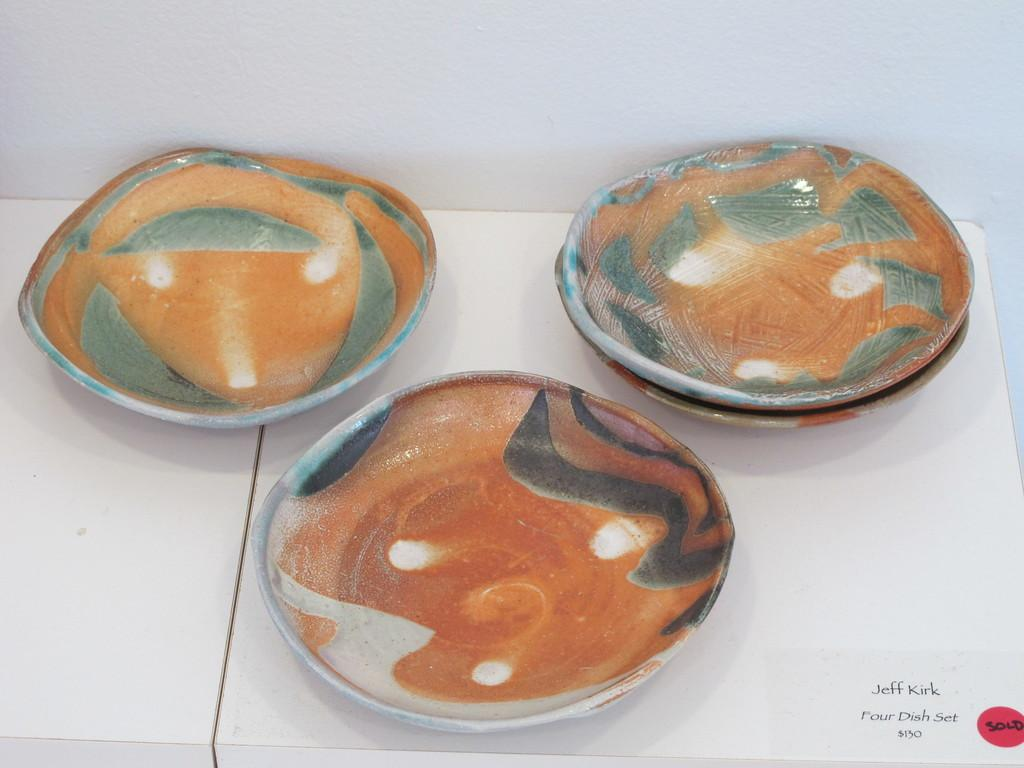What objects are present in the image? There are three mud saucers in the image. What can be said about the appearance of the mud saucers? The mud saucers are colorful. What is the color of the table in the image? The table is white. Where is the quote located on the table? There is a small quote on the bottom side of the table. How many children are playing with the mud saucers in the image? There are no children present in the image; it only shows the mud saucers and the table. What type of cart is used to transport the mud saucers in the image? There is no cart present in the image; the mud saucers are stationary on the table. 